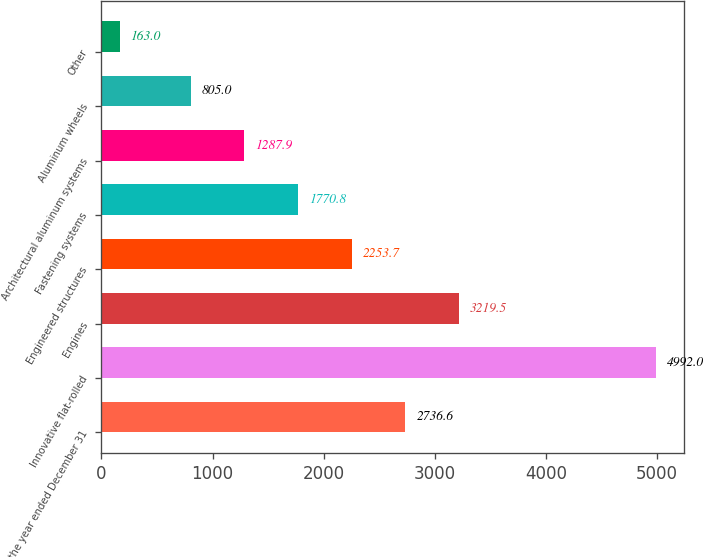Convert chart to OTSL. <chart><loc_0><loc_0><loc_500><loc_500><bar_chart><fcel>For the year ended December 31<fcel>Innovative flat-rolled<fcel>Engines<fcel>Engineered structures<fcel>Fastening systems<fcel>Architectural aluminum systems<fcel>Aluminum wheels<fcel>Other<nl><fcel>2736.6<fcel>4992<fcel>3219.5<fcel>2253.7<fcel>1770.8<fcel>1287.9<fcel>805<fcel>163<nl></chart> 